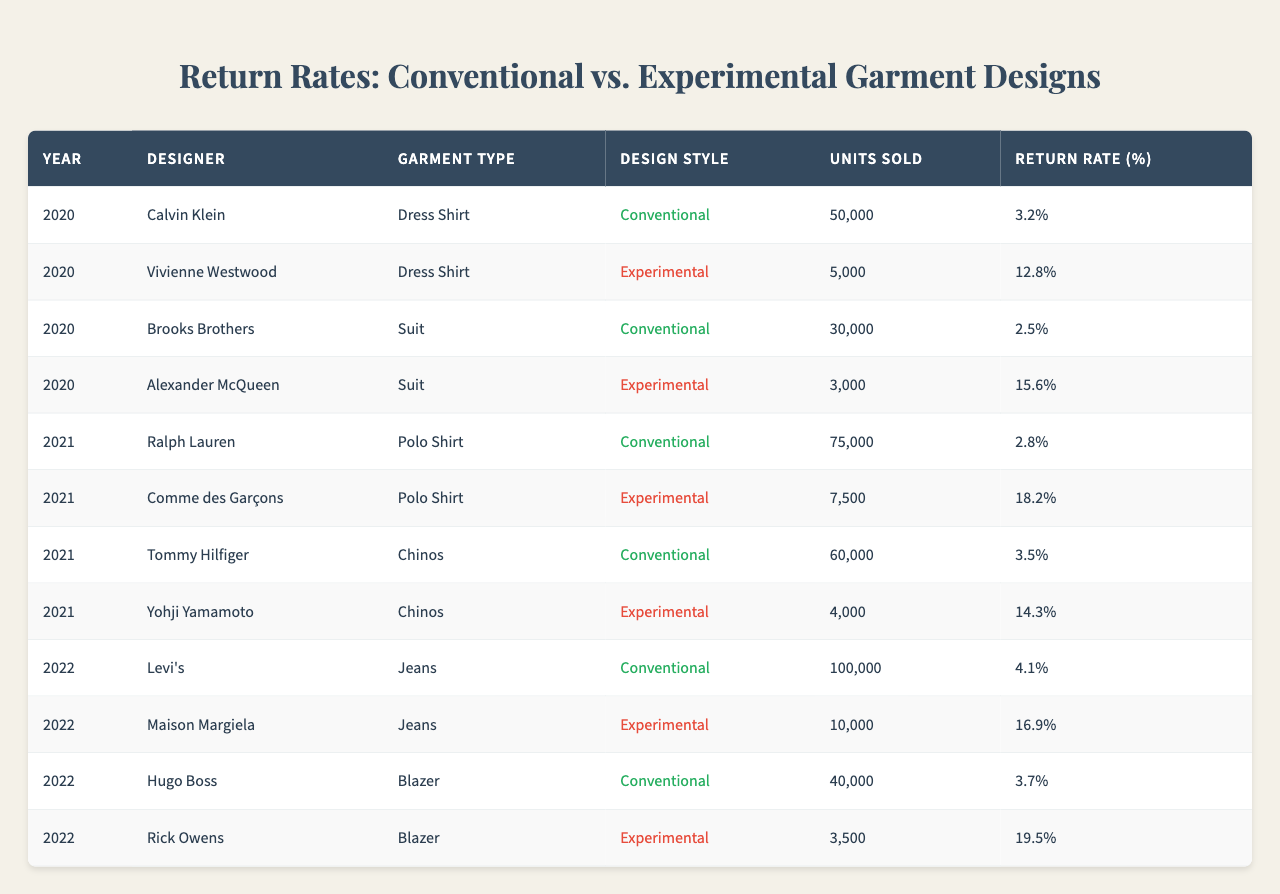What is the return rate for the Polo Shirt designed by Comme des Garçons? In the table, I can look at the row for Comme des Garçons under the Polo Shirt category, which shows a return rate of 18.2%.
Answer: 18.2% Which designer has the highest return rate for any garment type? By examining the return rates in the table, I can see that the highest return rate is from Rick Owens for the Blazer, which is 19.5%.
Answer: Rick Owens What is the total number of units sold for all conventional garment designs? To find this, I need to sum the units sold for conventional designs. The numbers are 50000 (Dress Shirt) + 30000 (Suit) + 75000 (Polo Shirt) + 60000 (Chinos) + 100000 (Jeans) + 40000 (Blazer) = 320000 units.
Answer: 320000 Was the return rate for experimental dress shirts lower than for experimental suits? Yes, the return rate for the experimental dress shirt designed by Vivienne Westwood is 12.8%, while the rate for the experimental suit by Alexander McQueen is 15.6%.
Answer: Yes What is the average return rate for all conventional garment designs? I find the return rates for conventional designs: 3.2%, 2.5%, 2.8%, 3.5%, 4.1%, and 3.7%. Adding these gives 20.8%. Then divide by the number of conventional garments (6) to find the average: 20.8% / 6 = 3.47%.
Answer: 3.47% How many more units were sold for conventional jeans compared to experimental jeans? From the table, conventional jeans sold 100000 units, and experimental jeans sold 10000 units. Therefore, subtracting gives 100000 - 10000 = 90000 more units sold.
Answer: 90000 Is there an experimental garment design that sold more than 50000 units? By reviewing the table, I can see that no experimental designs sold more than 50000 units, as the highest is 10000 units for experimental jeans.
Answer: No What percentage of units sold for Polo Shirts were in the experimental style compared to conventional? First, the units sold for conventional Polo Shirts is 75000, while for experimental it is 7500. The experimental proportion is (7500 / 75000) * 100, which equals 10%.
Answer: 10% Which conventional garment type has the second lowest return rate, and what is that rate? Looking through the conventional garment types, the return rates are: 3.2% for Dress Shirt, 2.5% for Suit, 2.8% for Polo Shirt, 3.5% for Chinos, 4.1% for Jeans, and 3.7% for Blazer. The second lowest is the Polo Shirt at 2.8%.
Answer: Polo Shirt, 2.8% How does the return rate of experimental designs compare to conventional designs overall? To determine this, I'd need to calculate the average return rates: The experimental average is (12.8 + 15.6 + 18.2 + 14.3 + 16.9 + 19.5) / 6 = 16.53%. The conventional average is 3.47%. Compared to conventional designs, experimental designs have a significantly higher average return rate.
Answer: Higher 